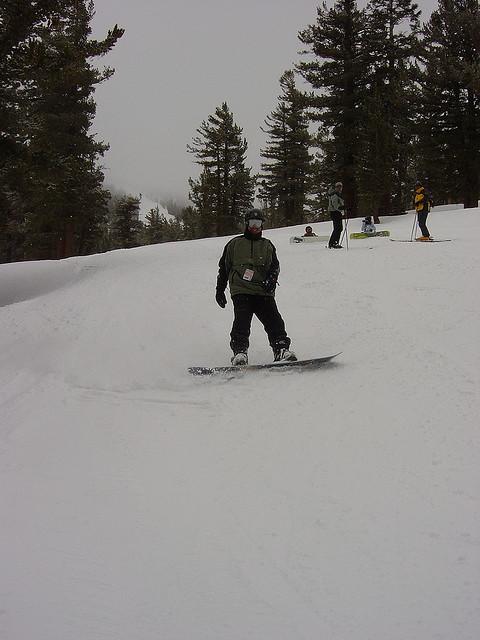Is the person taking the picture above or below the snowboarder?
Answer briefly. Below. Is he warm?
Keep it brief. Yes. What is the man wearing?
Concise answer only. Jacket. Is the snow dirty?
Concise answer only. No. Judging by the snowboarder's position, what is this snowboarder attempting to do?
Be succinct. Stop. What sport are these people playing?
Short answer required. Snowboarding. What color are the skier's boots?
Be succinct. White. What is he riding?
Write a very short answer. Snowboard. Are the trees covered in snow?
Give a very brief answer. No. Is the person skiing?
Short answer required. No. Is the snowboarder in the yellow jacket male or female?
Be succinct. Male. 